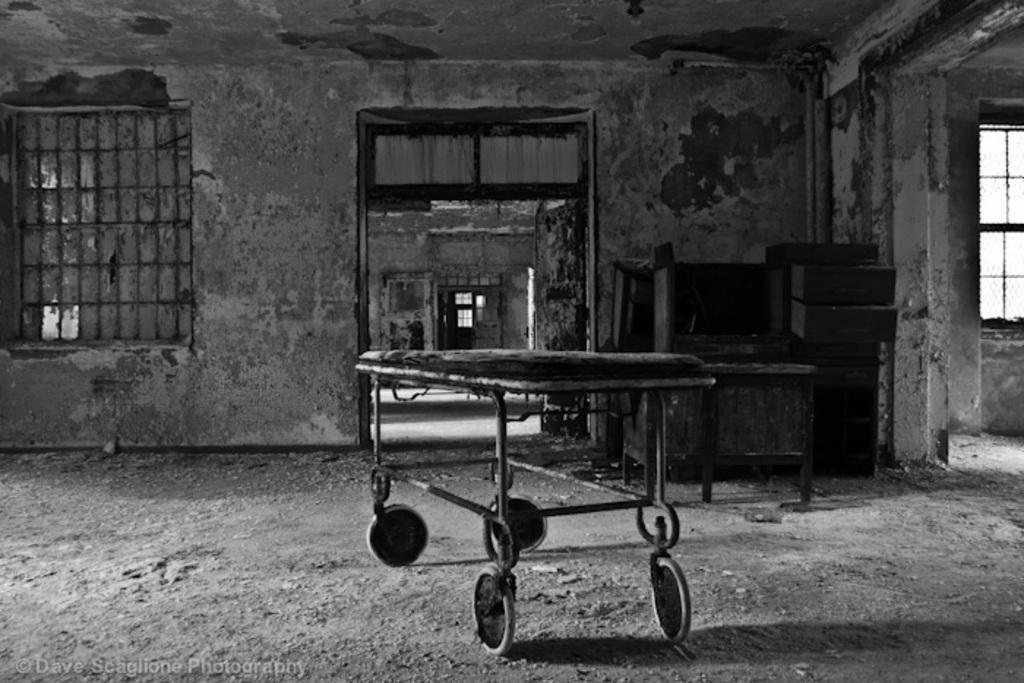What is the main object in the center of the image? There is a trolley in the center of the image. What can be seen on the right side of the image? There is a table on the right side of the image. What is placed on the table? There are things placed on the table. What architectural features are present in the image? There is a door and windows in the image. What type of disease is being treated on the trolley in the image? There is no indication of any disease or medical treatment in the image; it features a trolley and a table with items on it. How many teeth can be seen on the trolley in the image? There are no teeth visible on the trolley or anywhere else in the image. 